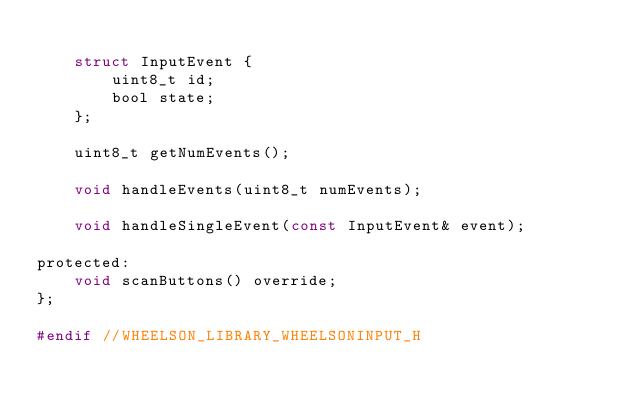<code> <loc_0><loc_0><loc_500><loc_500><_C_>
	struct InputEvent {
		uint8_t id;
		bool state;
	};

	uint8_t getNumEvents();

	void handleEvents(uint8_t numEvents);

	void handleSingleEvent(const InputEvent& event);

protected:
	void scanButtons() override;
};

#endif //WHEELSON_LIBRARY_WHEELSONINPUT_H
</code> 